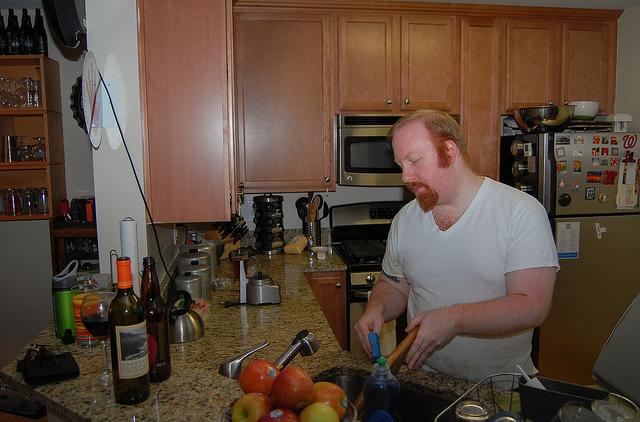Is this a kitchen in a private home?
Concise answer only. Yes. What's in the red bottle?
Be succinct. Wine. Is there a projector in the room?
Short answer required. No. How many wine glasses are there?
Write a very short answer. 1. What is the man with the bowl doing?
Concise answer only. Washing. Is the man on the phone?
Concise answer only. No. Is the bottle glass?
Quick response, please. Yes. Is the man holding a serving spoon in one of his hands?
Short answer required. No. Is he playing a video game?
Keep it brief. No. Is this picture taken outdoors?
Be succinct. No. What electronic is behind the man?
Concise answer only. Microwave. Are there any women in the photo?
Concise answer only. No. Is this a cafe?
Answer briefly. No. Where is this?
Give a very brief answer. Kitchen. What is this man holding?
Concise answer only. Sponge. Is this man brushing his teeth in the kitchen?
Give a very brief answer. No. Is the man wearing an earring?
Short answer required. No. What type of drink machine is in the background?
Short answer required. Coffee. What is the man doing with the cake knife?
Quick response, please. Nothing. Is this man happy?
Write a very short answer. Yes. Are there stripes on his shirt?
Answer briefly. No. What is this man doing?
Short answer required. Dishes. IS the table wood?
Keep it brief. No. Why are these wine glasses less than half full?
Keep it brief. Impossible. What is the object in the man's left hand?
Write a very short answer. Cutting board. Is the man happy?
Write a very short answer. Yes. What is being celebrated?
Concise answer only. Nothing. What does this man have up on the table?
Write a very short answer. Apples. What fruit is he cutting?
Short answer required. None. What color is the counter?
Answer briefly. Tan. What color is the dogs dish?
Write a very short answer. Silver. The fruit that is not sliced are called what?
Give a very brief answer. Apples. Is he eating?
Give a very brief answer. No. What is in the cup?
Be succinct. Wine. Is her purse white or brown?
Quick response, please. Brown. Is he in a kitchen?
Write a very short answer. Yes. Is there someone else in the kitchen?
Answer briefly. No. Is it on display?
Write a very short answer. No. How many mirrors are in the photo?
Concise answer only. 0. What is the man doing?
Keep it brief. Washing dishes. Is this man learning something new?
Be succinct. No. Is the male wearing glasses?
Short answer required. No. Is he baking a cake?
Be succinct. No. What is on the man's head?
Concise answer only. Hair. Whose kitchen is this?
Short answer required. Man's. What color is the man's hair?
Answer briefly. Red. Where is the man?
Write a very short answer. Kitchen. Is the man holding a cake?
Keep it brief. No. What kind of fruit is on the table?
Write a very short answer. Apples. What color is the wine?
Quick response, please. Red. What was likely placed in the silver metal bucket at the head of the table?
Answer briefly. Sugar. What color is the refrigerator?
Write a very short answer. Silver. What is in the metal container?
Be succinct. Flour. What kind of room is this?
Be succinct. Kitchen. Did the man order pizza?
Concise answer only. No. How many people are in the photo?
Give a very brief answer. 1. Is the bottle crushed?
Write a very short answer. No. Where is he looking?
Be succinct. Down. What color is the partition?
Keep it brief. White. How is the pattern on his shirt?
Give a very brief answer. Solid. How many wine bottles are on the table?
Give a very brief answer. 2. Does the man wear glasses?
Give a very brief answer. No. What fruit is being baked with?
Write a very short answer. Apples. Where is the man looking?
Keep it brief. Sink. What is the man cutting?
Be succinct. Fruit. Is this person's head above or below their waist?
Short answer required. Above. What is in his hand?
Write a very short answer. Sponge. What brand of beer do you see?
Quick response, please. Budweiser. How many sinks are in this photo?
Keep it brief. 1. What is standing next to the bottle?
Write a very short answer. Another bottle. How many cups?
Concise answer only. 2. What color is the man's shirt?
Short answer required. White. What do you feel when this food is eaten?
Write a very short answer. Good. What type of alcohol is in the bottle?
Be succinct. Wine. What brand is the juice?
Keep it brief. Minute maid. What color is the fruit basket?
Be succinct. Brown. What types of fruit can be seen in this picture?
Keep it brief. Apples. What is to the man's right?
Keep it brief. Counter. Is he a professional?
Answer briefly. No. What did the bearded man do to his sleeves?
Keep it brief. Nothing. Is the chef happy?
Answer briefly. Yes. How many different types of fruit are shown?
Keep it brief. 1. How many bottles are on the table?
Quick response, please. 2. Is there a microwave on the counter?
Concise answer only. No. What is written on the boys shirt?
Short answer required. Nothing. Is there a window in this photo?
Quick response, please. No. Is the beer bottle half empty?
Keep it brief. No. What function might those scissors be used for in particular?
Be succinct. Cutting. Where will the meal be eaten?
Concise answer only. Dining room. What race is the man?
Keep it brief. White. What color shirt is this person wearing?
Short answer required. White. Are these men sitting?
Short answer required. No. What is the man cutting up?
Quick response, please. Apples. What is the countertop made out of?
Answer briefly. Granite. What is the man holding?
Short answer required. Sponge. What is in the bottle on top of the counter?
Be succinct. Wine. What kind of food is shown?
Give a very brief answer. Apples. What kind of wine is the man drinking?
Give a very brief answer. Red. What kind of wine are they using?
Give a very brief answer. Red. Is there a knife missing from the knife block?
Give a very brief answer. No. Is this a water bottle?
Concise answer only. No. What is on top of the microwave?
Keep it brief. Cabinets. How many bottles of wine are in the picture?
Short answer required. 1. What kind of classic wine is listed on the advertisement about the wine dispenser?
Be succinct. Red. Is the balding man yelling?
Write a very short answer. No. Is there a screen in the room?
Keep it brief. No. What is he holding?
Concise answer only. Sponge. Is the man playing Nintendo Wii?
Answer briefly. No. What fruit is in the bowl?
Write a very short answer. Apples. What color is the wall in the background?
Give a very brief answer. White. What fruit is in a bowl on the counter?
Concise answer only. Apples. How many people are in this image?
Give a very brief answer. 1. What sex is the food preparer?
Be succinct. Male. In an earthquake, which item would roll?
Keep it brief. Apples. What is on the man's wrist?
Keep it brief. Nothing. What color are the cabinets?
Concise answer only. Brown. What kind of device is the man holding in his hands?
Be succinct. Sponge. Are there bottles of liquor on the counter?
Quick response, please. Yes. Is the man unhappy?
Quick response, please. No. What color is the wall?
Be succinct. White. Is there a mug in this picture full of writing utensils?
Answer briefly. No. How many stoves are there?
Keep it brief. 1. What type of event was this?
Write a very short answer. Dinner. Is the man overweight?
Give a very brief answer. Yes. What kind of controller is she holding?
Be succinct. None. 